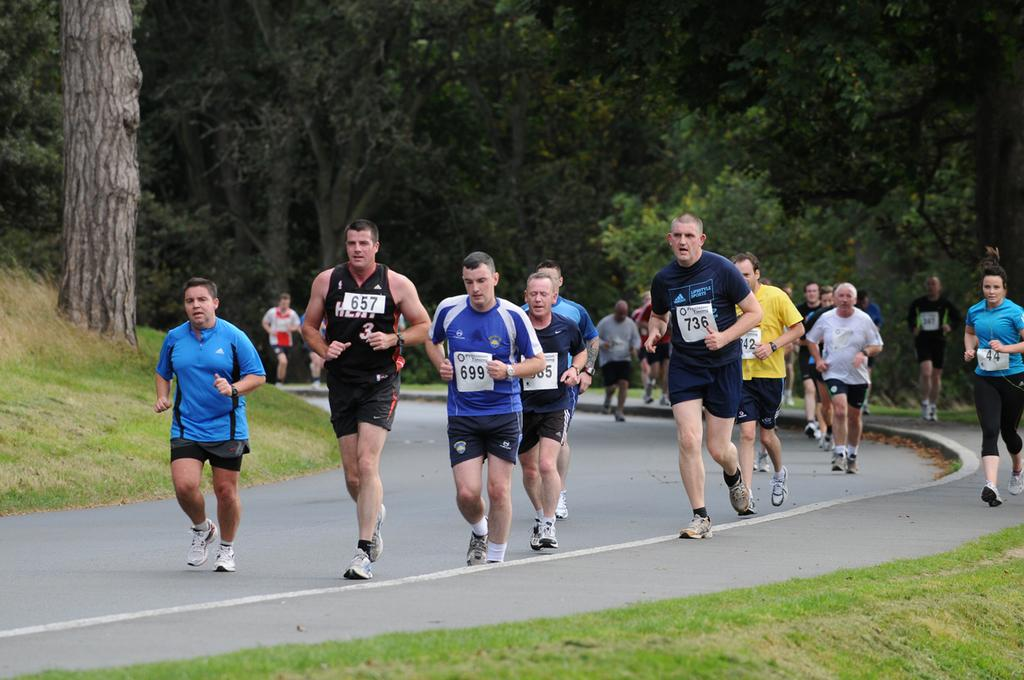What is happening with the groups of people in the image? The people are running on the road in the image. What can be seen behind the people? There are trees behind the people in the image. What type of surface are the people running on? The people are running on a road in the image. What is the natural environment visible in the image? There is grass visible in the image. What news is the actor reading in the image? There is no actor or news present in the image; it features groups of people running on a road with trees and grass in the background. 